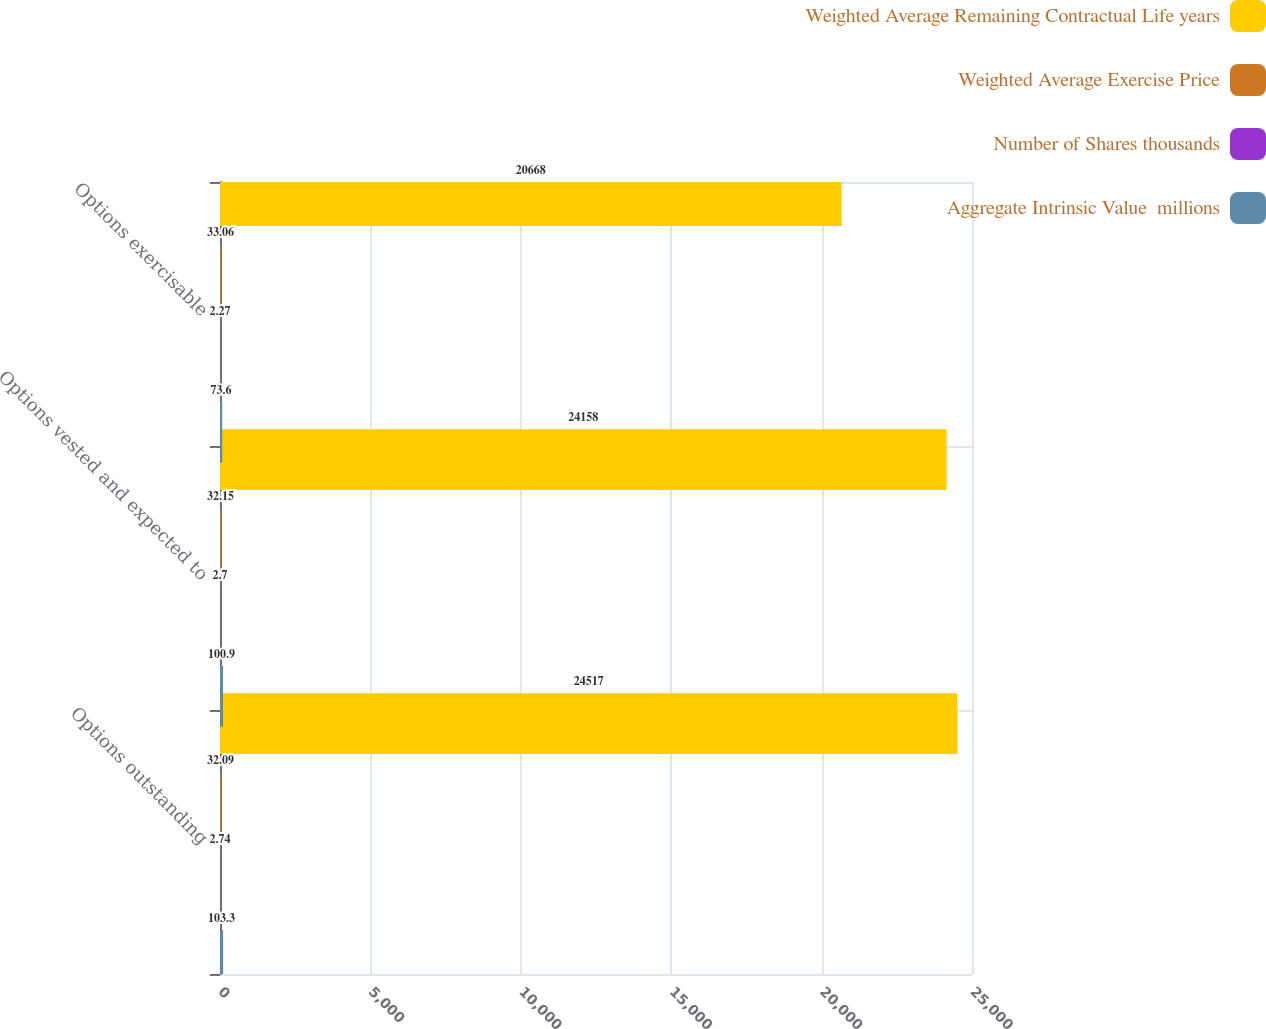<chart> <loc_0><loc_0><loc_500><loc_500><stacked_bar_chart><ecel><fcel>Options outstanding<fcel>Options vested and expected to<fcel>Options exercisable<nl><fcel>Weighted Average Remaining Contractual Life years<fcel>24517<fcel>24158<fcel>20668<nl><fcel>Weighted Average Exercise Price<fcel>32.09<fcel>32.15<fcel>33.06<nl><fcel>Number of Shares thousands<fcel>2.74<fcel>2.7<fcel>2.27<nl><fcel>Aggregate Intrinsic Value  millions<fcel>103.3<fcel>100.9<fcel>73.6<nl></chart> 